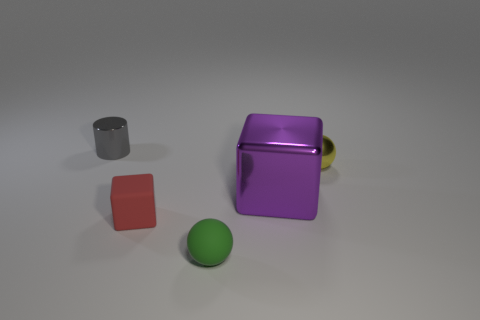Add 1 blocks. How many objects exist? 6 Subtract all cylinders. How many objects are left? 4 Subtract 1 cubes. How many cubes are left? 1 Subtract 0 yellow blocks. How many objects are left? 5 Subtract all brown cylinders. Subtract all cyan blocks. How many cylinders are left? 1 Subtract all small gray things. Subtract all large blue rubber balls. How many objects are left? 4 Add 4 tiny red objects. How many tiny red objects are left? 5 Add 5 big purple objects. How many big purple objects exist? 6 